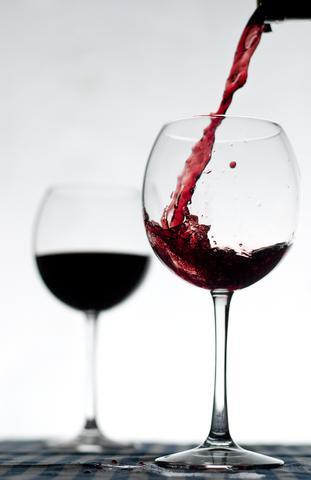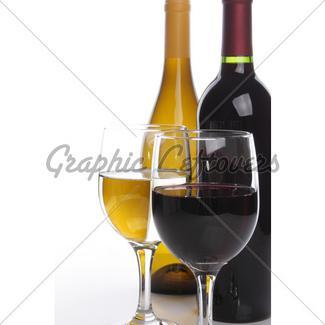The first image is the image on the left, the second image is the image on the right. Evaluate the accuracy of this statement regarding the images: "An image includes two glasses of wine, at least one bunch of grapes, and one wine bottle.". Is it true? Answer yes or no. No. The first image is the image on the left, the second image is the image on the right. Evaluate the accuracy of this statement regarding the images: "Wine is being poured in a wine glass in one of the images.". Is it true? Answer yes or no. Yes. 